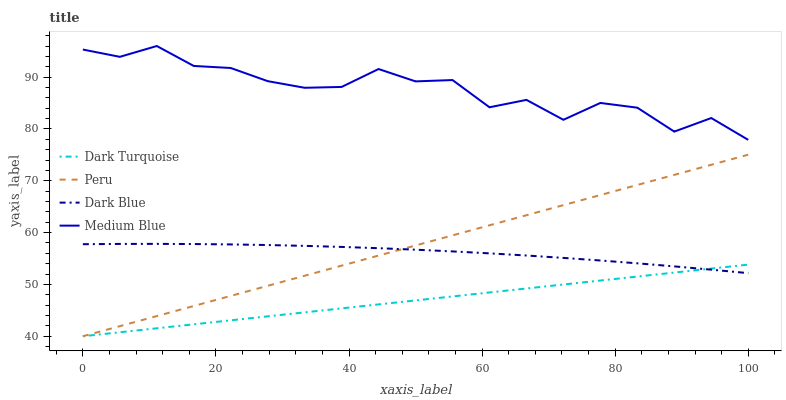Does Dark Turquoise have the minimum area under the curve?
Answer yes or no. Yes. Does Medium Blue have the maximum area under the curve?
Answer yes or no. Yes. Does Peru have the minimum area under the curve?
Answer yes or no. No. Does Peru have the maximum area under the curve?
Answer yes or no. No. Is Peru the smoothest?
Answer yes or no. Yes. Is Medium Blue the roughest?
Answer yes or no. Yes. Is Medium Blue the smoothest?
Answer yes or no. No. Is Peru the roughest?
Answer yes or no. No. Does Dark Turquoise have the lowest value?
Answer yes or no. Yes. Does Medium Blue have the lowest value?
Answer yes or no. No. Does Medium Blue have the highest value?
Answer yes or no. Yes. Does Peru have the highest value?
Answer yes or no. No. Is Dark Blue less than Medium Blue?
Answer yes or no. Yes. Is Medium Blue greater than Dark Blue?
Answer yes or no. Yes. Does Dark Turquoise intersect Peru?
Answer yes or no. Yes. Is Dark Turquoise less than Peru?
Answer yes or no. No. Is Dark Turquoise greater than Peru?
Answer yes or no. No. Does Dark Blue intersect Medium Blue?
Answer yes or no. No. 